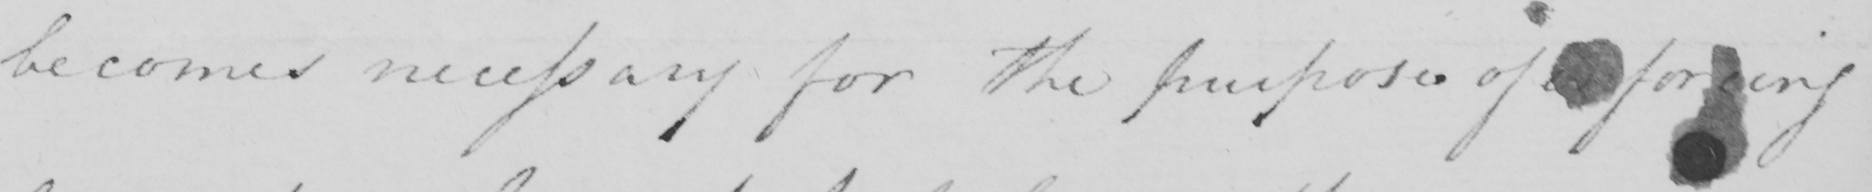Can you read and transcribe this handwriting? becomes necessary for the purpose of inforcing 